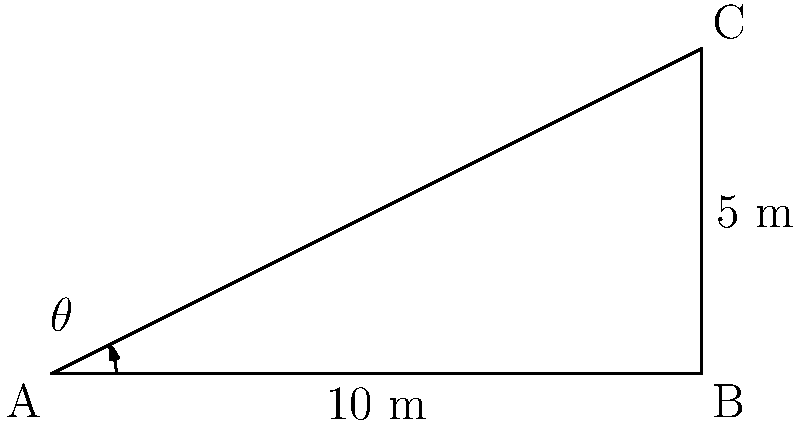As part of an ethical investment initiative, you're assessing a company's plan to install a solar panel array on their roof. The array is shaped like a right-angled triangle with a base of 10 meters and a height of 5 meters. What is the area of this solar panel array in square meters? Round your answer to two decimal places. To solve this problem, we'll use the formula for the area of a triangle:

$$\text{Area} = \frac{1}{2} \times \text{base} \times \text{height}$$

Given:
- Base = 10 meters
- Height = 5 meters

Step 1: Plug the values into the formula
$$\text{Area} = \frac{1}{2} \times 10 \times 5$$

Step 2: Perform the multiplication
$$\text{Area} = \frac{1}{2} \times 50 = 25$$

Therefore, the area of the solar panel array is 25 square meters.

Note: While this problem doesn't directly use trigonometric functions, it relates to trigonometry as the right-angled triangle could be solved using trigonometric ratios if different information was given (e.g., if we had an angle and the hypotenuse instead of the base and height).
Answer: 25 m² 